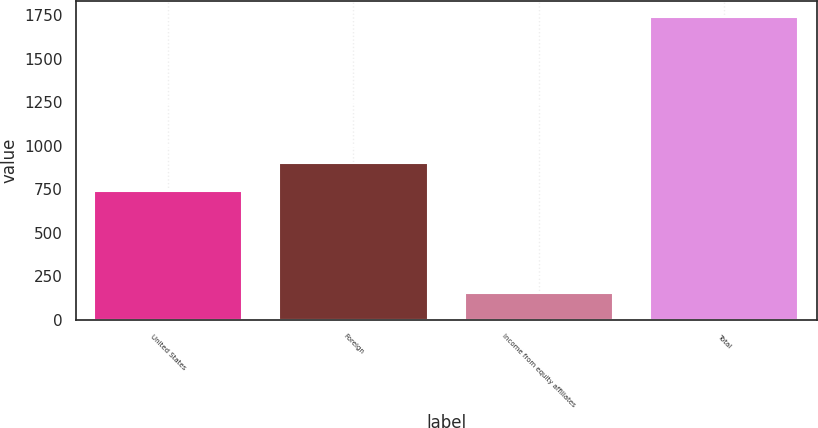Convert chart to OTSL. <chart><loc_0><loc_0><loc_500><loc_500><bar_chart><fcel>United States<fcel>Foreign<fcel>Income from equity affiliates<fcel>Total<nl><fcel>742<fcel>900.82<fcel>154.5<fcel>1742.7<nl></chart> 